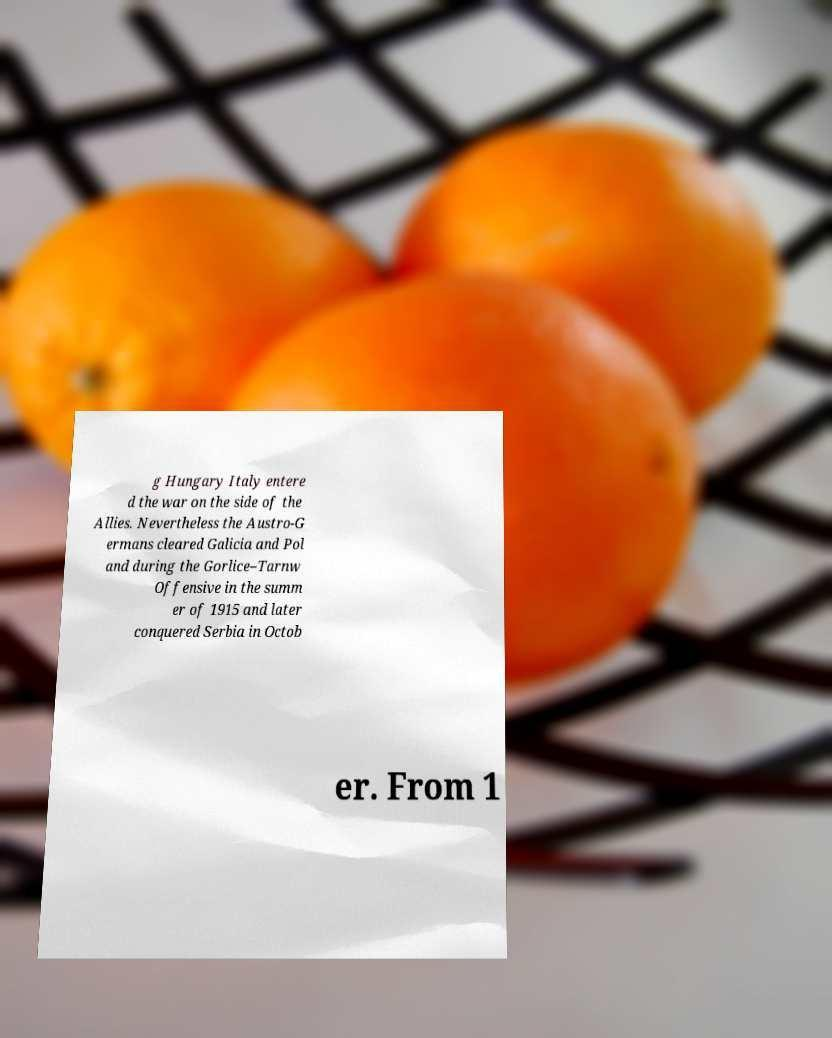Can you accurately transcribe the text from the provided image for me? g Hungary Italy entere d the war on the side of the Allies. Nevertheless the Austro-G ermans cleared Galicia and Pol and during the Gorlice–Tarnw Offensive in the summ er of 1915 and later conquered Serbia in Octob er. From 1 